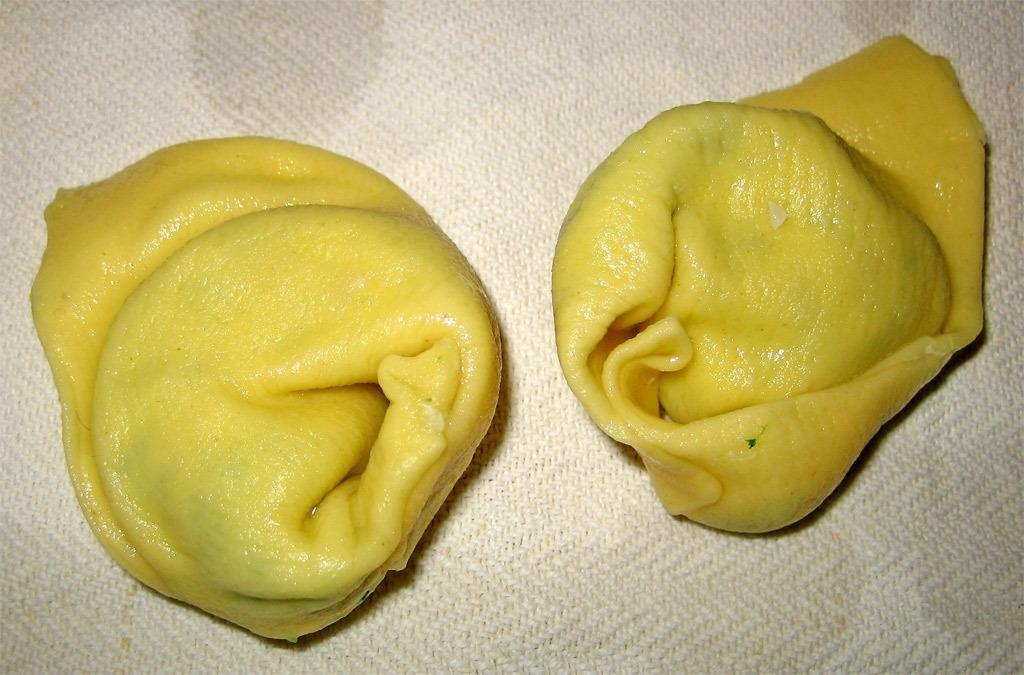What can be seen in the image related to food? There are two food items in the image. Where are the food items placed? The food items are on a cloth. How does the nut transport the food items in the image? There is no nut present in the image, and therefore it cannot transport the food items. 